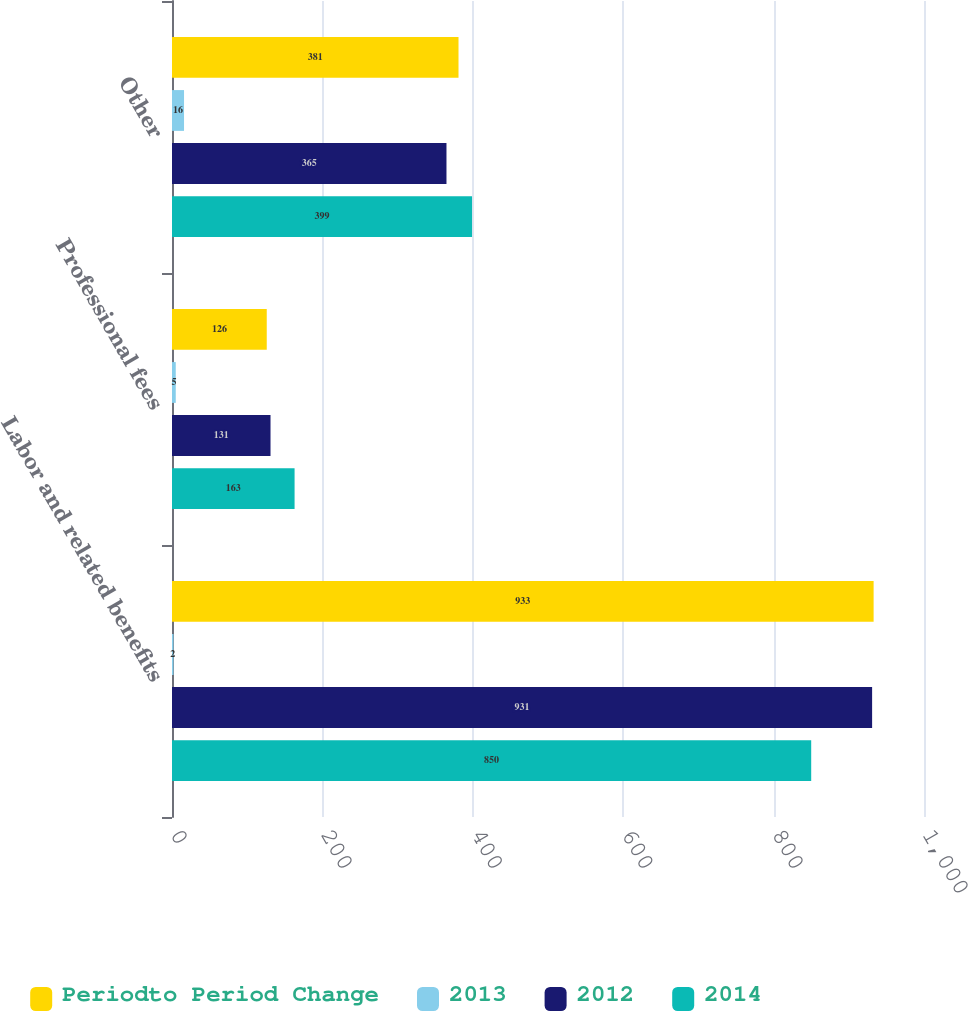<chart> <loc_0><loc_0><loc_500><loc_500><stacked_bar_chart><ecel><fcel>Labor and related benefits<fcel>Professional fees<fcel>Other<nl><fcel>Periodto Period Change<fcel>933<fcel>126<fcel>381<nl><fcel>2013<fcel>2<fcel>5<fcel>16<nl><fcel>2012<fcel>931<fcel>131<fcel>365<nl><fcel>2014<fcel>850<fcel>163<fcel>399<nl></chart> 